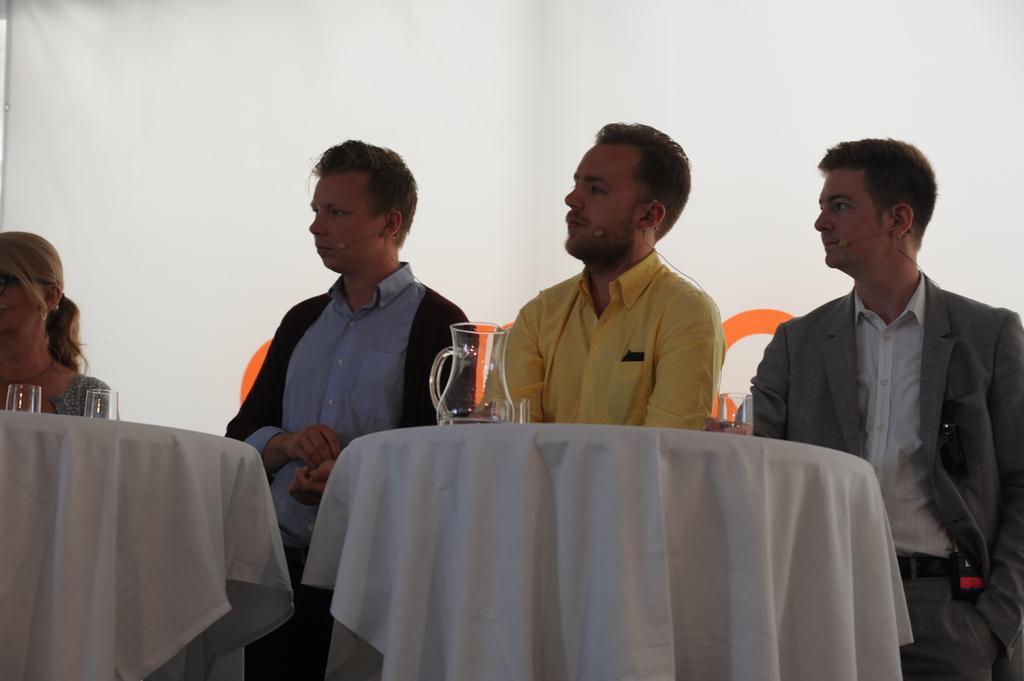Please provide a concise description of this image. As we can see in the image there is a cloth, few people sitting on chair and there is a table. On table there are glasses. 